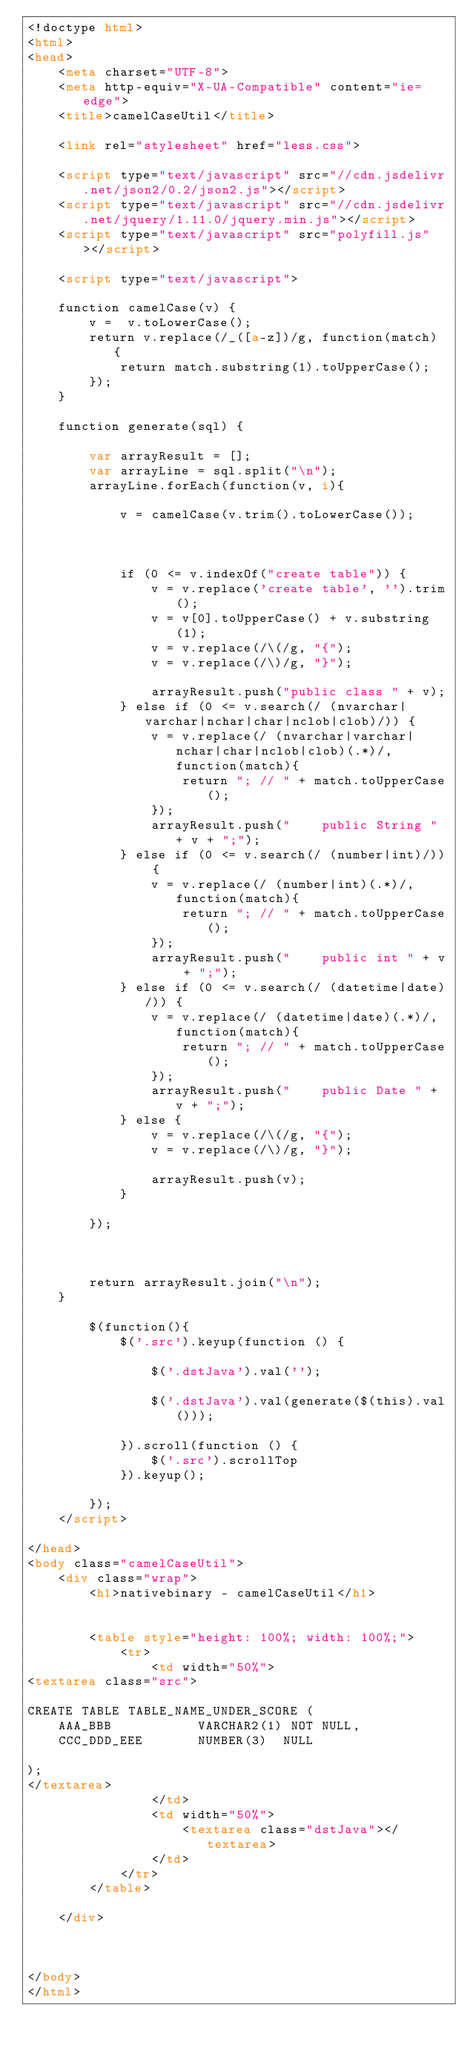Convert code to text. <code><loc_0><loc_0><loc_500><loc_500><_HTML_><!doctype html>
<html>
<head>
    <meta charset="UTF-8">
    <meta http-equiv="X-UA-Compatible" content="ie=edge">
    <title>camelCaseUtil</title>

    <link rel="stylesheet" href="less.css">

    <script type="text/javascript" src="//cdn.jsdelivr.net/json2/0.2/json2.js"></script>
    <script type="text/javascript" src="//cdn.jsdelivr.net/jquery/1.11.0/jquery.min.js"></script>
    <script type="text/javascript" src="polyfill.js"></script>

    <script type="text/javascript">

    function camelCase(v) {
        v =  v.toLowerCase();
        return v.replace(/_([a-z])/g, function(match) {
            return match.substring(1).toUpperCase();
        });
    }

    function generate(sql) {

        var arrayResult = [];
        var arrayLine = sql.split("\n");
        arrayLine.forEach(function(v, i){

            v = camelCase(v.trim().toLowerCase());



            if (0 <= v.indexOf("create table")) {
                v = v.replace('create table', '').trim();
                v = v[0].toUpperCase() + v.substring(1);
                v = v.replace(/\(/g, "{");
                v = v.replace(/\)/g, "}");

                arrayResult.push("public class " + v);
            } else if (0 <= v.search(/ (nvarchar|varchar|nchar|char|nclob|clob)/)) {
                v = v.replace(/ (nvarchar|varchar|nchar|char|nclob|clob)(.*)/, function(match){
                    return "; // " + match.toUpperCase();
                });
                arrayResult.push("    public String " + v + ";");
            } else if (0 <= v.search(/ (number|int)/)) {
                v = v.replace(/ (number|int)(.*)/, function(match){
                    return "; // " + match.toUpperCase();
                });
                arrayResult.push("    public int " + v + ";");
            } else if (0 <= v.search(/ (datetime|date)/)) {
                v = v.replace(/ (datetime|date)(.*)/, function(match){
                    return "; // " + match.toUpperCase();
                });
                arrayResult.push("    public Date " + v + ";");
            } else {
                v = v.replace(/\(/g, "{");
                v = v.replace(/\)/g, "}");

                arrayResult.push(v);
            }

        });
        


        return arrayResult.join("\n");
    }

        $(function(){
            $('.src').keyup(function () {
                
                $('.dstJava').val('');

                $('.dstJava').val(generate($(this).val()));

            }).scroll(function () {
                $('.src').scrollTop
            }).keyup();
            
        });
    </script>

</head>
<body class="camelCaseUtil">
    <div class="wrap">
        <h1>nativebinary - camelCaseUtil</h1>


        <table style="height: 100%; width: 100%;">
            <tr>
                <td width="50%">
<textarea class="src">

CREATE TABLE TABLE_NAME_UNDER_SCORE (
    AAA_BBB           VARCHAR2(1) NOT NULL,
    CCC_DDD_EEE       NUMBER(3)  NULL
    
);
</textarea>
                </td>
                <td width="50%">
                    <textarea class="dstJava"></textarea>
                </td>
            </tr>
        </table>

    </div>



</body>
</html>
</code> 